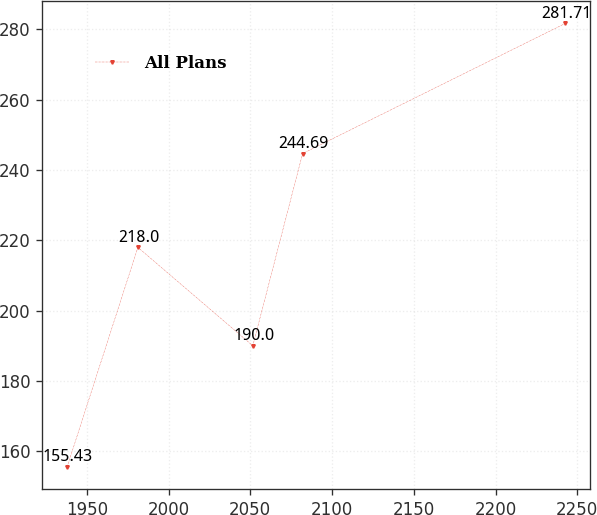Convert chart. <chart><loc_0><loc_0><loc_500><loc_500><line_chart><ecel><fcel>All Plans<nl><fcel>1937.92<fcel>155.43<nl><fcel>1981.26<fcel>218<nl><fcel>2051.53<fcel>190<nl><fcel>2081.99<fcel>244.69<nl><fcel>2242.55<fcel>281.71<nl></chart> 